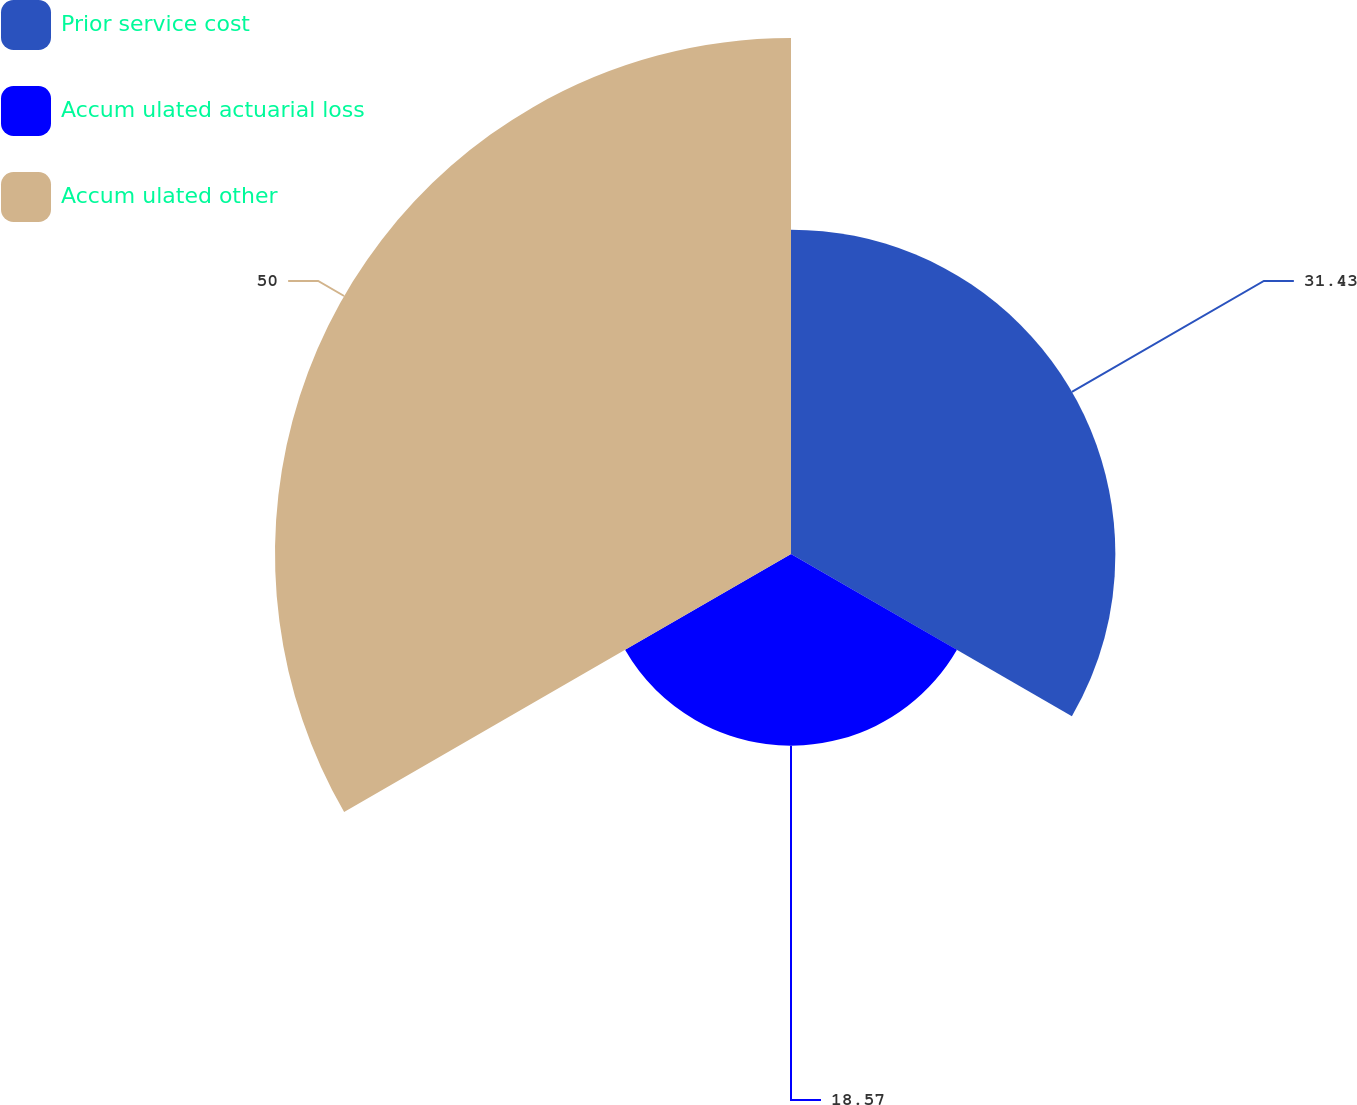Convert chart to OTSL. <chart><loc_0><loc_0><loc_500><loc_500><pie_chart><fcel>Prior service cost<fcel>Accum ulated actuarial loss<fcel>Accum ulated other<nl><fcel>31.43%<fcel>18.57%<fcel>50.0%<nl></chart> 